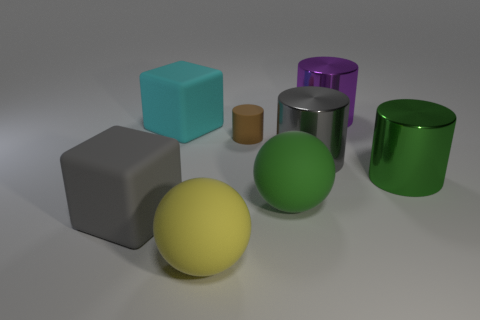Do the gray thing that is in front of the large green sphere and the large matte object that is in front of the large gray rubber object have the same shape?
Your answer should be compact. No. What number of things are yellow balls or balls to the left of the small rubber cylinder?
Make the answer very short. 1. What number of other objects are the same shape as the purple metallic object?
Make the answer very short. 3. Do the gray thing behind the green cylinder and the cyan cube have the same material?
Offer a terse response. No. How many things are balls or large metallic things?
Offer a very short reply. 5. What is the size of the brown object that is the same shape as the purple metal object?
Provide a succinct answer. Small. The gray cylinder has what size?
Make the answer very short. Large. Are there more large cylinders that are in front of the large cyan matte object than green metallic things?
Ensure brevity in your answer.  Yes. Do the large ball that is right of the yellow thing and the cylinder on the right side of the purple shiny cylinder have the same color?
Your answer should be compact. Yes. What material is the cylinder that is on the right side of the thing behind the rubber cube behind the large gray cylinder made of?
Offer a terse response. Metal. 